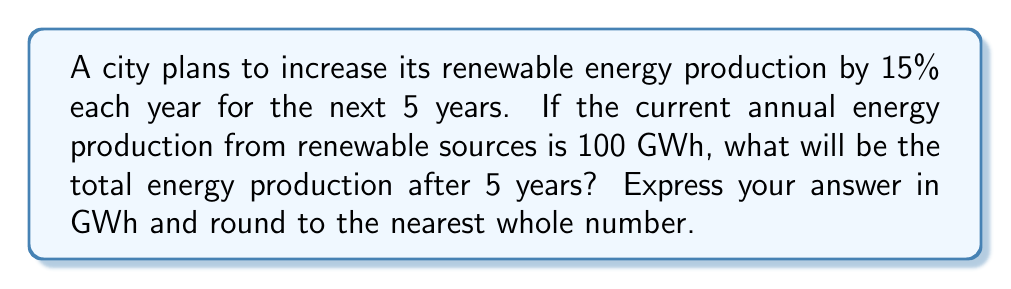Help me with this question. Let's approach this step-by-step:

1) The annual increase is 15%, so the scaling factor for each year is 1.15 (100% + 15% = 115% = 1.15).

2) We need to apply this scaling factor for 5 consecutive years. This can be represented as an exponential function:

   $$ 100 \cdot (1.15)^5 $$

3) Let's calculate this:
   $$ 100 \cdot (1.15)^5 = 100 \cdot 2.0113... $$

4) Multiplying:
   $$ = 201.13... $$

5) Rounding to the nearest whole number:
   $$ \approx 201 \text{ GWh} $$

This calculation demonstrates how exponential growth can significantly increase energy production over time, highlighting the potential of consistent investment in renewable energy sources.
Answer: 201 GWh 